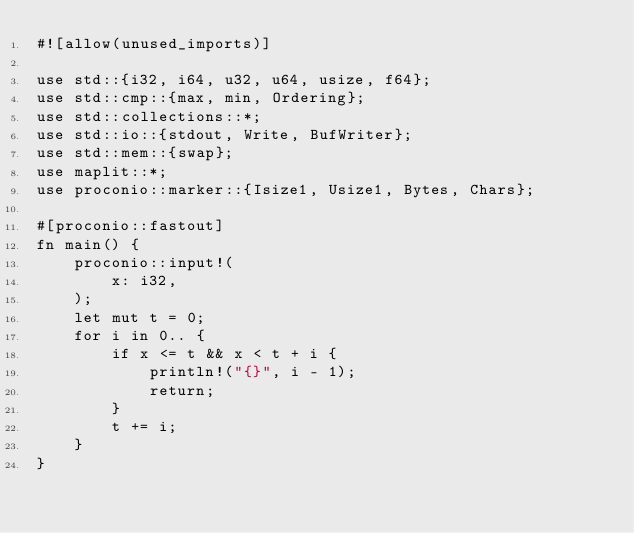<code> <loc_0><loc_0><loc_500><loc_500><_Rust_>#![allow(unused_imports)]

use std::{i32, i64, u32, u64, usize, f64};
use std::cmp::{max, min, Ordering};
use std::collections::*;
use std::io::{stdout, Write, BufWriter};
use std::mem::{swap};
use maplit::*;
use proconio::marker::{Isize1, Usize1, Bytes, Chars};

#[proconio::fastout]
fn main() {
    proconio::input!(
        x: i32,
    );
    let mut t = 0;
    for i in 0.. {
        if x <= t && x < t + i {
            println!("{}", i - 1);
            return;
        }
        t += i;
    }
}
</code> 